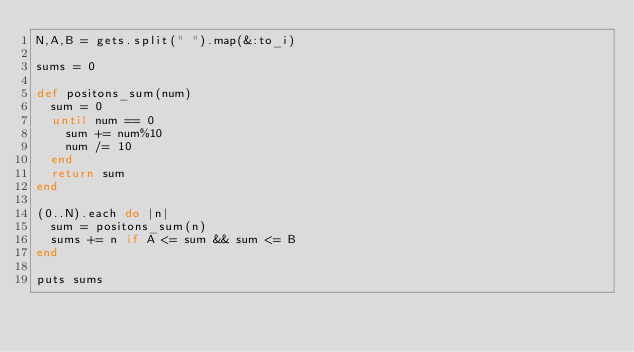Convert code to text. <code><loc_0><loc_0><loc_500><loc_500><_Ruby_>N,A,B = gets.split(" ").map(&:to_i)

sums = 0

def positons_sum(num)
  sum = 0
  until num == 0
    sum += num%10
    num /= 10
  end
  return sum
end

(0..N).each do |n|
  sum = positons_sum(n)
  sums += n if A <= sum && sum <= B
end

puts sums
</code> 